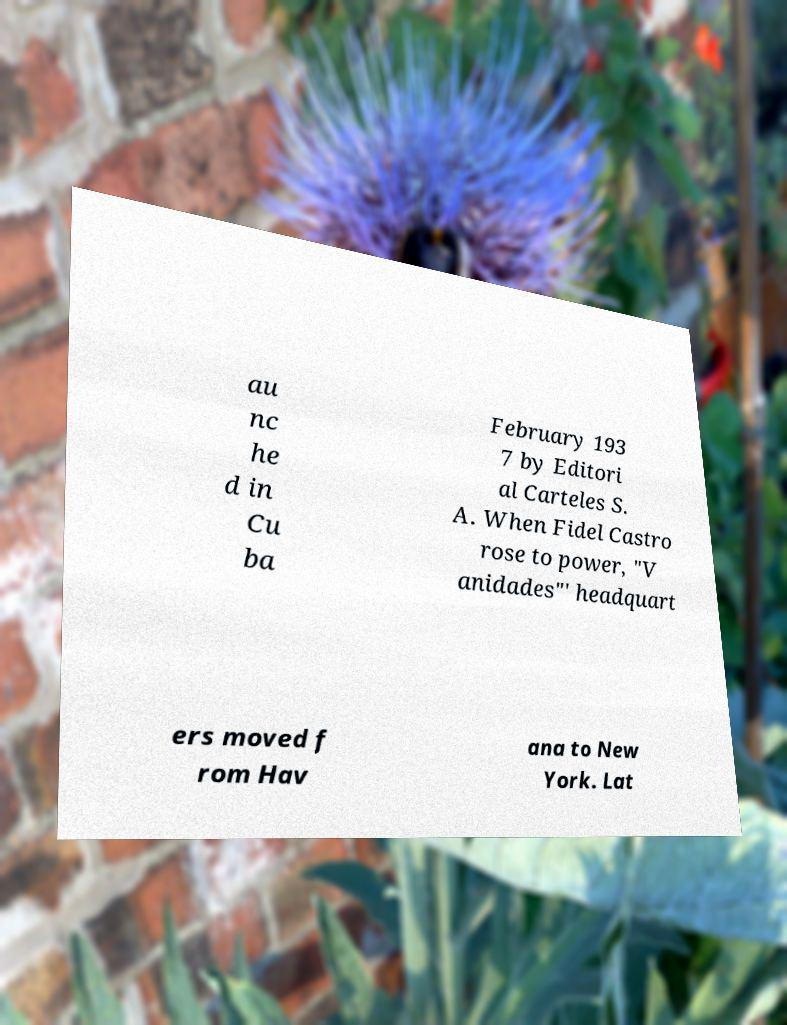For documentation purposes, I need the text within this image transcribed. Could you provide that? au nc he d in Cu ba February 193 7 by Editori al Carteles S. A. When Fidel Castro rose to power, "V anidades"' headquart ers moved f rom Hav ana to New York. Lat 